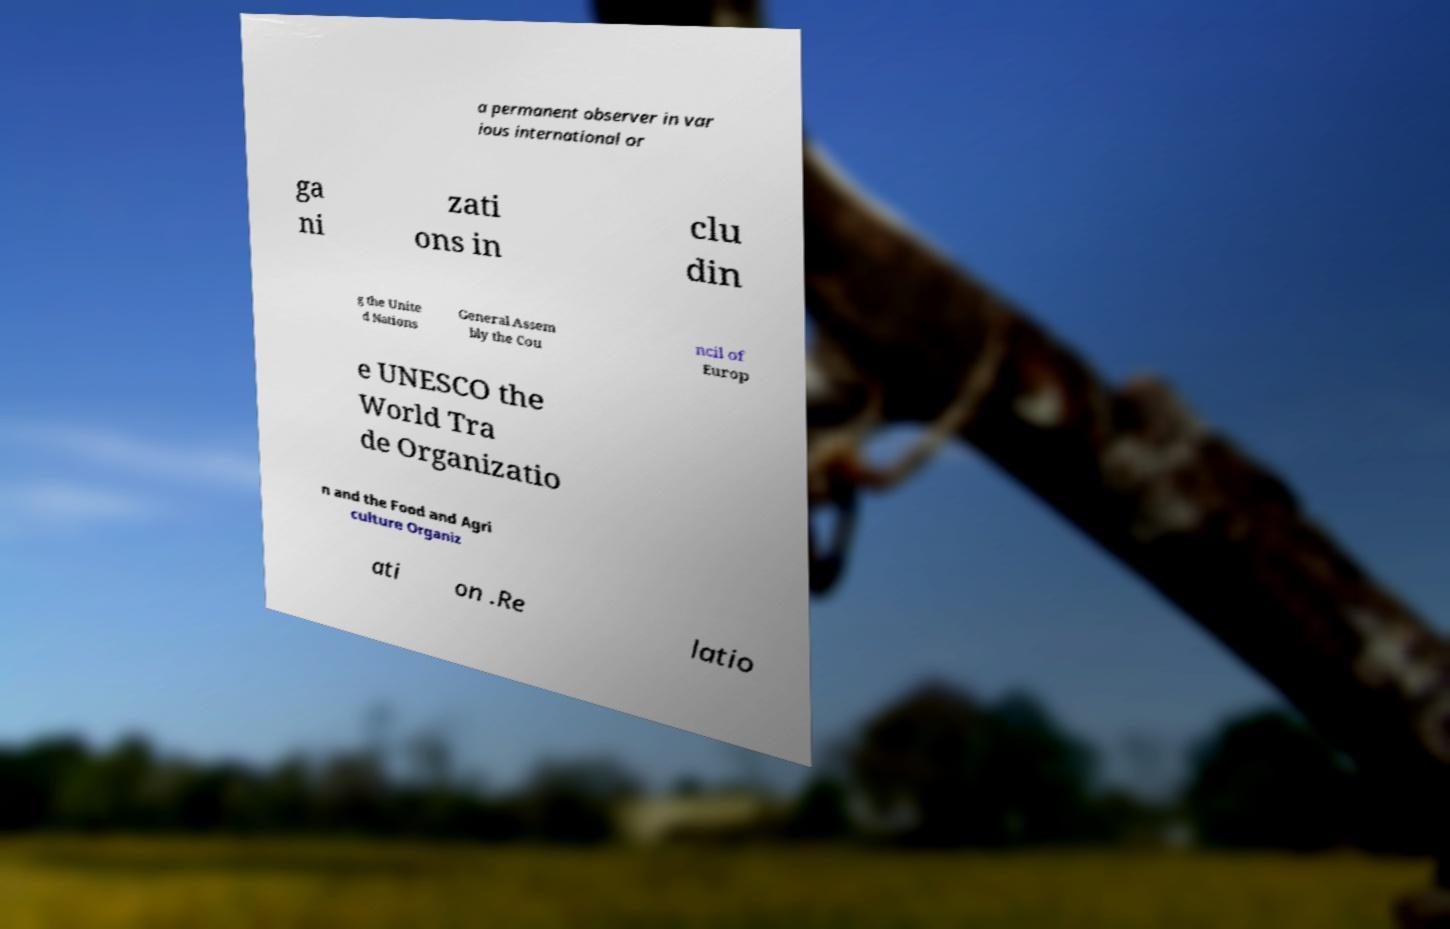Please identify and transcribe the text found in this image. a permanent observer in var ious international or ga ni zati ons in clu din g the Unite d Nations General Assem bly the Cou ncil of Europ e UNESCO the World Tra de Organizatio n and the Food and Agri culture Organiz ati on .Re latio 